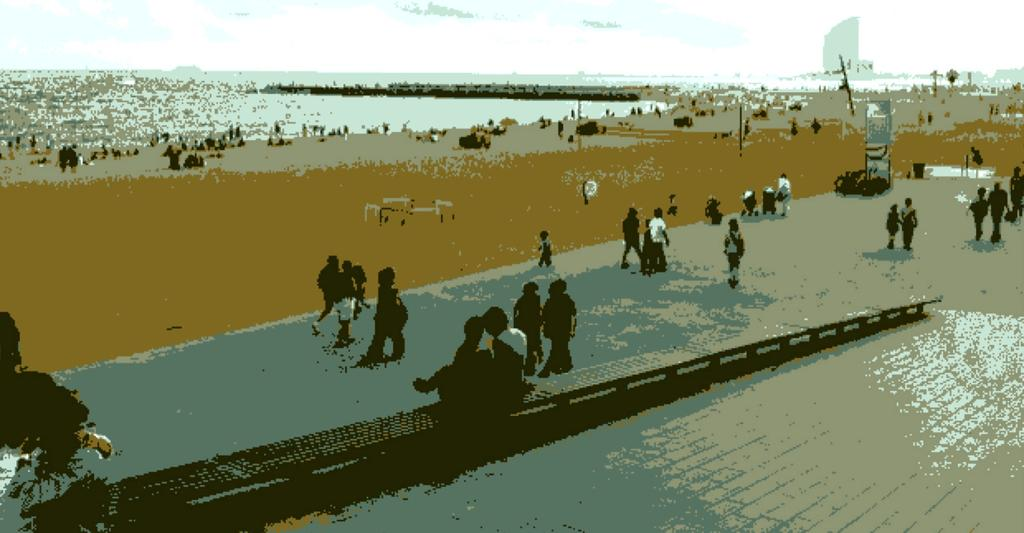What type of image is displayed in the picture? The image contains an animated picture of a group of persons. Where are the persons in the image located? The persons are standing on the ground. What can be seen in the background of the image? There is water, a group of poles, at least one building, and the sky visible in the background of the image. What type of donkey can be seen carrying a pail in the image? There is no donkey or pail present in the image; it features an animated picture of a group of persons standing on the ground with various elements visible in the background. 